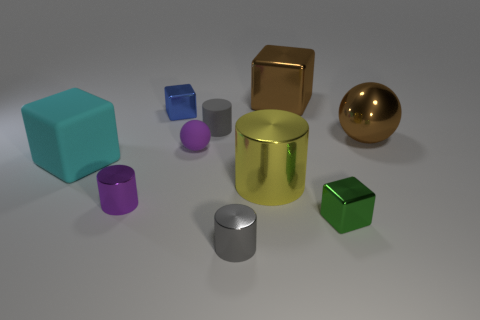Do the big yellow metallic object and the tiny gray object to the left of the gray shiny thing have the same shape?
Ensure brevity in your answer.  Yes. How many other objects are there of the same shape as the large yellow metallic thing?
Your answer should be compact. 3. There is a metal thing that is both behind the big yellow shiny cylinder and left of the big shiny cube; what is its color?
Make the answer very short. Blue. What is the color of the matte cylinder?
Your answer should be compact. Gray. Are the yellow object and the tiny gray cylinder that is in front of the tiny purple shiny cylinder made of the same material?
Keep it short and to the point. Yes. What is the shape of the small gray thing that is the same material as the large sphere?
Provide a short and direct response. Cylinder. What is the color of the rubber ball that is the same size as the purple metallic thing?
Provide a succinct answer. Purple. Does the gray thing that is in front of the cyan matte thing have the same size as the green metallic thing?
Your answer should be very brief. Yes. Is the large metal cube the same color as the big sphere?
Provide a short and direct response. Yes. What number of large matte blocks are there?
Offer a terse response. 1. 